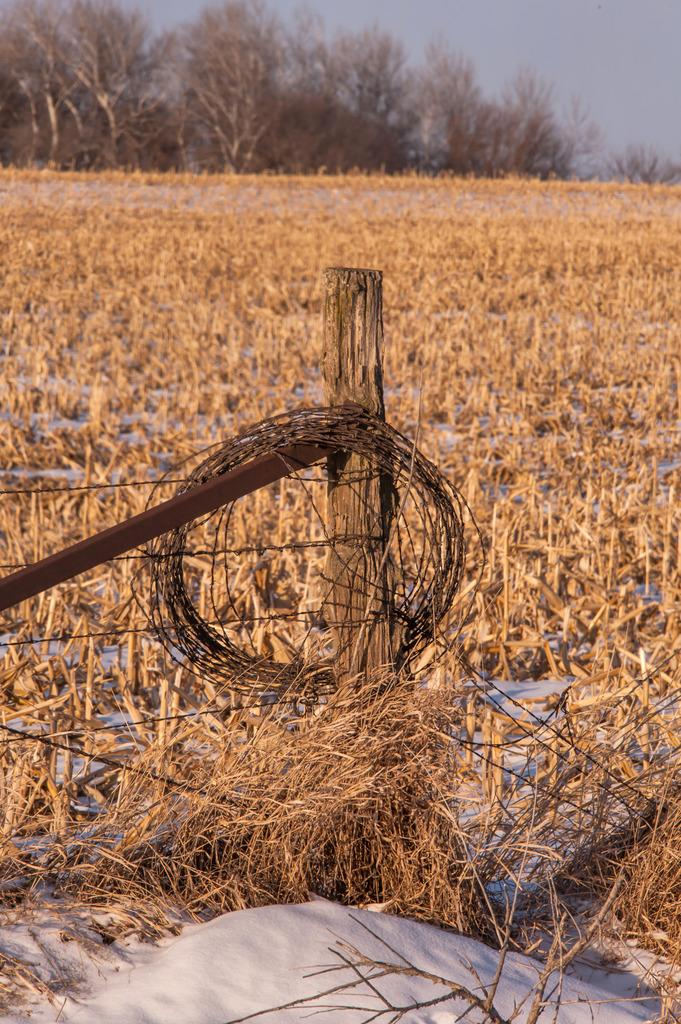What is located on the left side of the image? There are fencing wires on the left side of the image. What type of vegetation can be seen in the image? There is grass visible in the image. What can be seen in the background of the image? There are trees and the sky visible in the background of the image. What is the size of the cable in the image? There is no cable present in the image. How does the grass push against the fencing wires in the image? The grass does not push against the fencing wires in the image; it is stationary vegetation. 